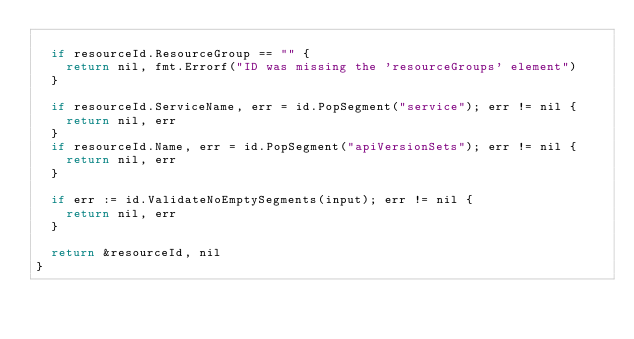<code> <loc_0><loc_0><loc_500><loc_500><_Go_>
	if resourceId.ResourceGroup == "" {
		return nil, fmt.Errorf("ID was missing the 'resourceGroups' element")
	}

	if resourceId.ServiceName, err = id.PopSegment("service"); err != nil {
		return nil, err
	}
	if resourceId.Name, err = id.PopSegment("apiVersionSets"); err != nil {
		return nil, err
	}

	if err := id.ValidateNoEmptySegments(input); err != nil {
		return nil, err
	}

	return &resourceId, nil
}
</code> 